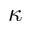Convert formula to latex. <formula><loc_0><loc_0><loc_500><loc_500>\kappa</formula> 